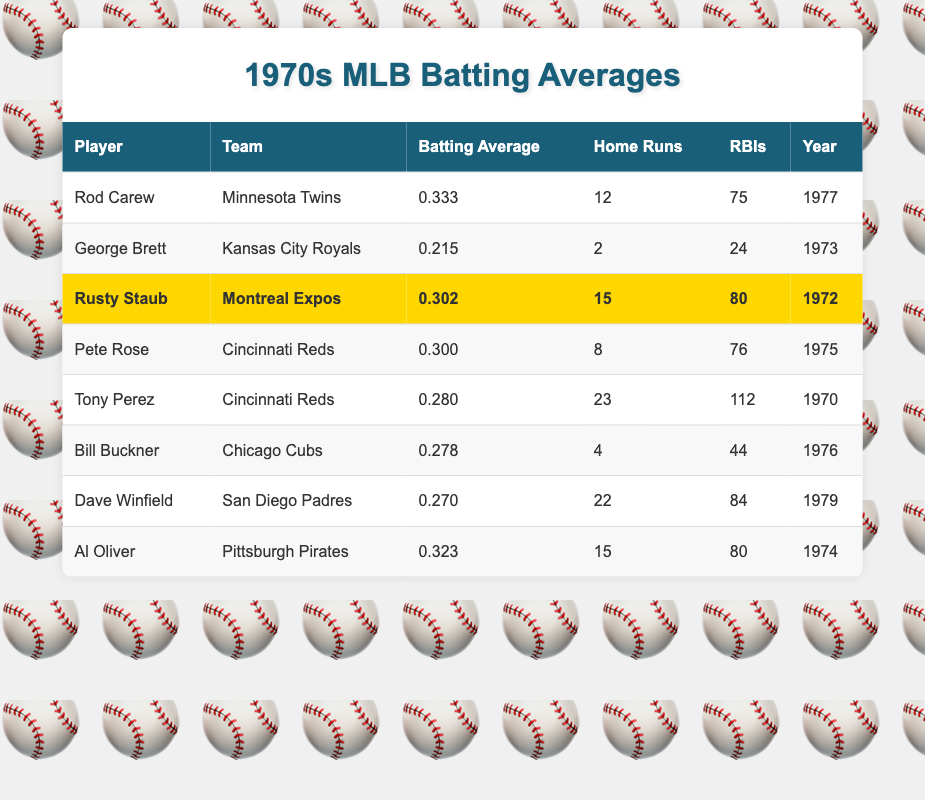What was Rusty Staub's batting average in 1972? The table shows that Rusty Staub had a batting average of 0.302 during the year 1972.
Answer: 0.302 Which player on the Cincinnati Reds had the best batting average in the given years? According to the table, Pete Rose had a batting average of 0.300 in 1975, which is higher than Tony Perez's 0.280 in 1970. Therefore, Pete Rose had the best batting average among Cincinnati Reds players listed.
Answer: Pete Rose How many home runs did Al Oliver hit in 1974? The table indicates that Al Oliver hit 15 home runs during the year 1974.
Answer: 15 Did George Brett have a better batting average than Rusty Staub? The table shows George Brett with a batting average of 0.215, which is lower than Rusty Staub's 0.302 in 1972. Therefore, George Brett did not have a better average.
Answer: No What is the average batting average of the players listed in the table? To find the average, sum up all batting averages: (0.333 + 0.215 + 0.302 + 0.300 + 0.280 + 0.278 + 0.270 + 0.323) = 2.801. There are 8 players, so the average batting average is 2.801 / 8 = 0.350125. Rounding to three decimal places gives 0.350.
Answer: 0.350 Which player had the most RBIs in the 1970s and how many? The highest number of RBIs is found for Tony Perez who had 112 RBIs in 1970. By checking all entries, no player had more RBIs than him.
Answer: Tony Perez, 112 How many more home runs did Dave Winfield hit than Bill Buckner? The data shows that Dave Winfield hit 22 home runs while Bill Buckner hit 4. The difference is 22 - 4 = 18. Thus, Dave Winfield hit 18 more home runs than Bill Buckner.
Answer: 18 